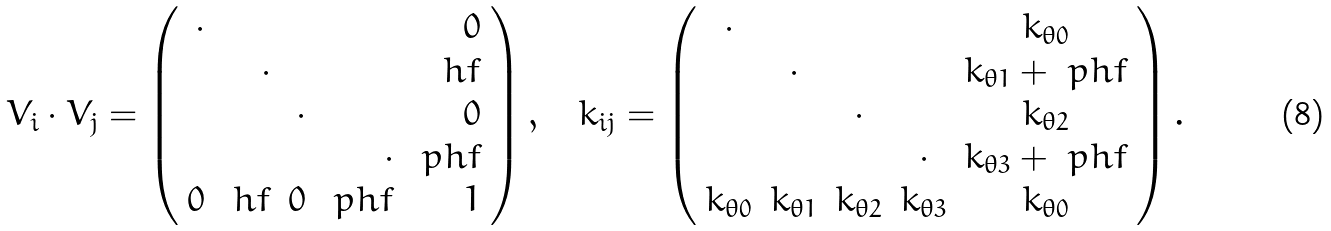Convert formula to latex. <formula><loc_0><loc_0><loc_500><loc_500>V _ { i } \cdot V _ { j } = \left ( \begin{array} { r r r r r } \cdot & & & & 0 \\ & \cdot & & & \ h f \\ & & \cdot & & 0 \\ & & & \cdot & \ p h f \\ 0 & \ h f & 0 & \ p h f & 1 \end{array} \right ) , \quad k _ { i j } = \left ( \begin{array} { c c c c c } \cdot & & & & k _ { \theta 0 } \\ & \cdot & & & k _ { \theta 1 } + \ p h f \\ & & \cdot & & k _ { \theta 2 } \\ & & & \cdot & k _ { \theta 3 } + \ p h f \\ k _ { \theta 0 } & k _ { \theta 1 } & k _ { \theta 2 } & k _ { \theta 3 } & k _ { \theta 0 } \end{array} \right ) .</formula> 